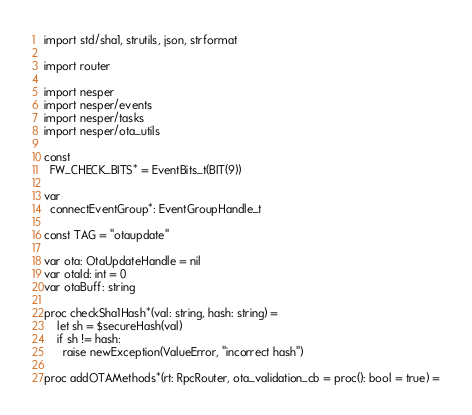Convert code to text. <code><loc_0><loc_0><loc_500><loc_500><_Nim_>import std/sha1, strutils, json, strformat

import router

import nesper
import nesper/events
import nesper/tasks
import nesper/ota_utils

const
  FW_CHECK_BITS* = EventBits_t(BIT(9))

var
  connectEventGroup*: EventGroupHandle_t

const TAG = "otaupdate"

var ota: OtaUpdateHandle = nil
var otaId: int = 0
var otaBuff: string

proc checkSha1Hash*(val: string, hash: string) =
    let sh = $secureHash(val)
    if sh != hash:
      raise newException(ValueError, "incorrect hash")

proc addOTAMethods*(rt: RpcRouter, ota_validation_cb = proc(): bool = true) =
</code> 